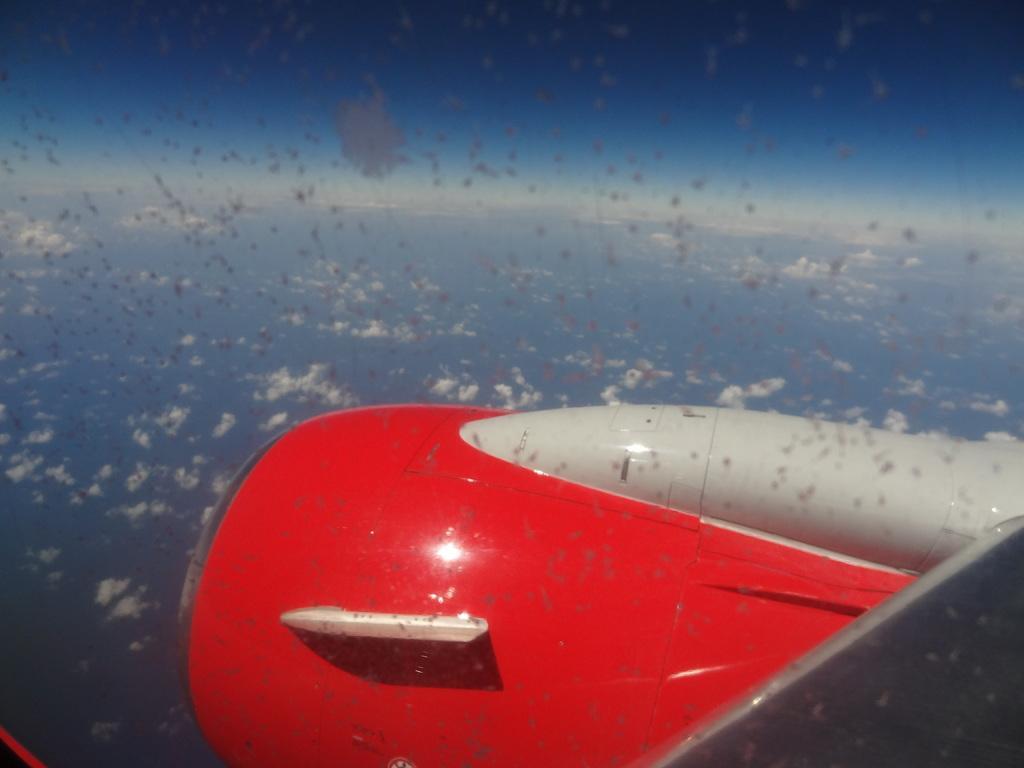In one or two sentences, can you explain what this image depicts? In this image there is the sky, there are clouds in the sky, there is an aircraft towards the bottom of the image. 